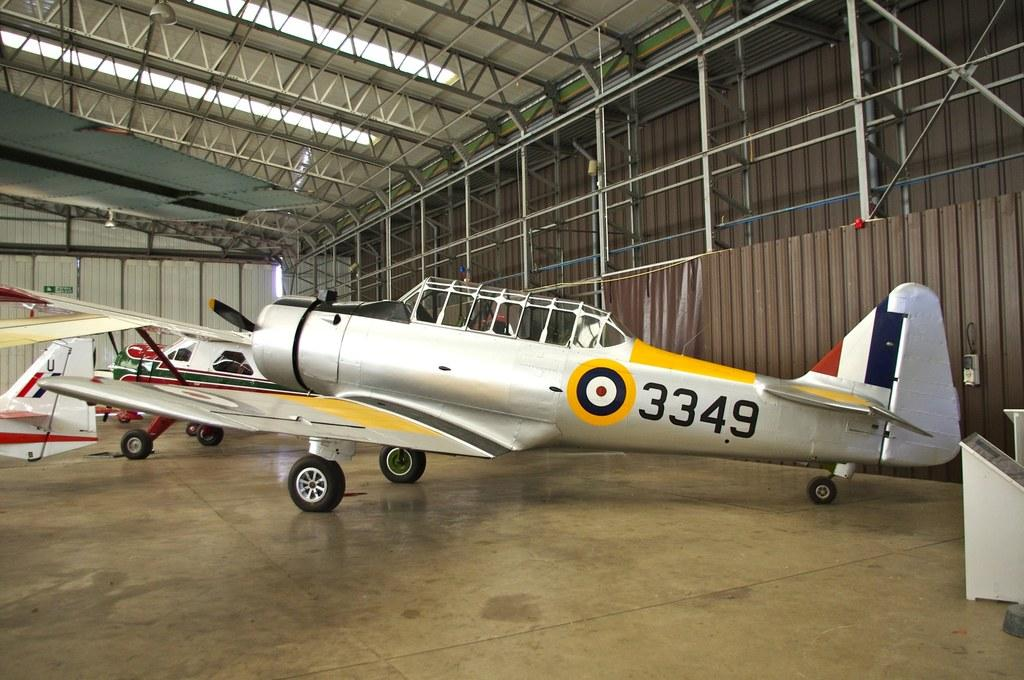What objects are on the floor in the image? There are aircrafts on the floor in the image. What is attached to the iron wall in the image? There is a sign board on an iron wall in the image. What can be seen at the top of the image? There is a light visible at the top of the image. What type of material is used for the rods in the image? There are iron rods visible in the image. What is the nutritional value of the aircrafts in the image? The aircrafts in the image are not food items, so they do not have a nutritional value. Is there a chain visible in the image? There is no chain present in the image. 